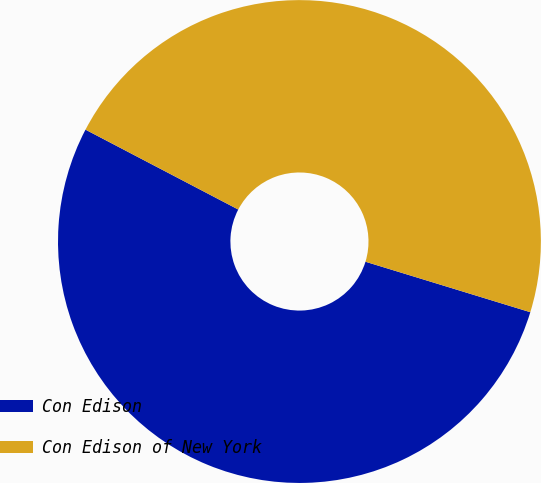<chart> <loc_0><loc_0><loc_500><loc_500><pie_chart><fcel>Con Edison<fcel>Con Edison of New York<nl><fcel>52.94%<fcel>47.06%<nl></chart> 